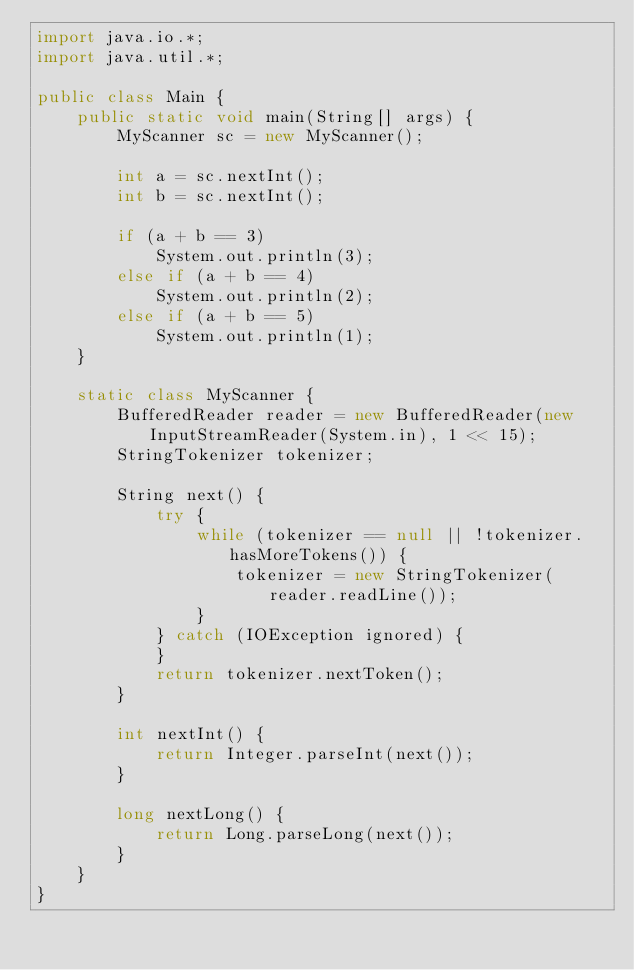Convert code to text. <code><loc_0><loc_0><loc_500><loc_500><_Java_>import java.io.*;
import java.util.*;

public class Main {
    public static void main(String[] args) {
        MyScanner sc = new MyScanner();

        int a = sc.nextInt();
        int b = sc.nextInt();

        if (a + b == 3)
            System.out.println(3);
        else if (a + b == 4)
            System.out.println(2);
        else if (a + b == 5)
            System.out.println(1);
    }

    static class MyScanner {
        BufferedReader reader = new BufferedReader(new InputStreamReader(System.in), 1 << 15);
        StringTokenizer tokenizer;

        String next() {
            try {
                while (tokenizer == null || !tokenizer.hasMoreTokens()) {
                    tokenizer = new StringTokenizer(reader.readLine());
                }
            } catch (IOException ignored) {
            }
            return tokenizer.nextToken();
        }

        int nextInt() {
            return Integer.parseInt(next());
        }

        long nextLong() {
            return Long.parseLong(next());
        }
    }
}</code> 